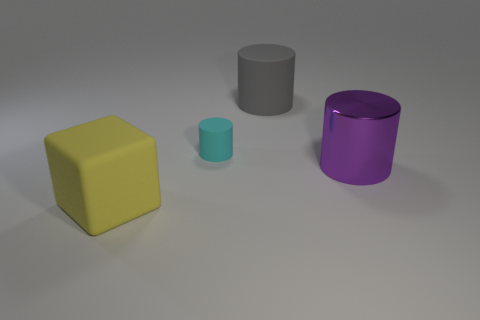Is there anything else that has the same material as the large purple thing?
Keep it short and to the point. No. What is the material of the cylinder that is to the right of the gray matte thing?
Your response must be concise. Metal. There is a large object behind the big metal cylinder; does it have the same shape as the object to the right of the gray rubber cylinder?
Give a very brief answer. Yes. Are there the same number of purple metal things that are behind the purple metal cylinder and tiny cyan balls?
Your response must be concise. Yes. How many small cyan things have the same material as the yellow thing?
Your answer should be compact. 1. The cube that is made of the same material as the big gray object is what color?
Your answer should be compact. Yellow. Do the yellow cube and the object that is to the right of the gray rubber cylinder have the same size?
Ensure brevity in your answer.  Yes. What is the shape of the tiny cyan object?
Provide a short and direct response. Cylinder. There is another tiny object that is the same shape as the gray matte thing; what color is it?
Your answer should be compact. Cyan. There is a matte thing that is behind the cyan rubber cylinder; how many yellow rubber cubes are right of it?
Provide a short and direct response. 0. 